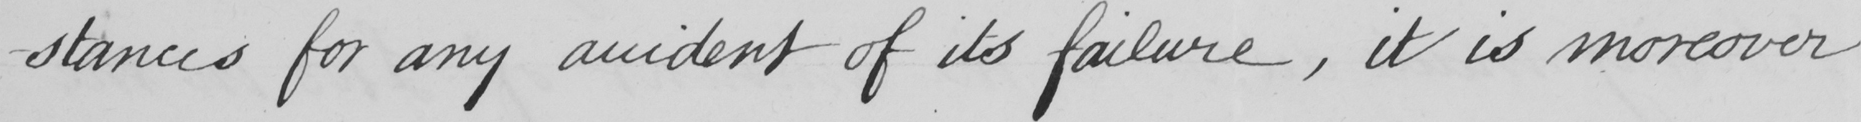What does this handwritten line say? -stances for any accident of its failure , it is moreover 